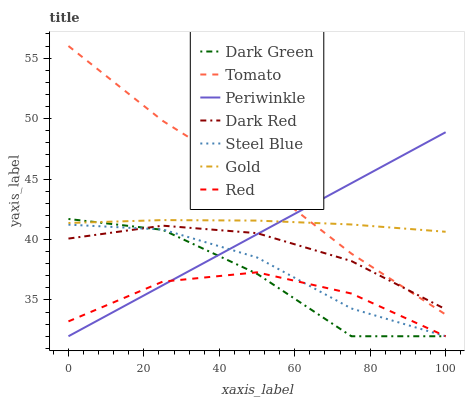Does Red have the minimum area under the curve?
Answer yes or no. Yes. Does Tomato have the maximum area under the curve?
Answer yes or no. Yes. Does Gold have the minimum area under the curve?
Answer yes or no. No. Does Gold have the maximum area under the curve?
Answer yes or no. No. Is Periwinkle the smoothest?
Answer yes or no. Yes. Is Dark Green the roughest?
Answer yes or no. Yes. Is Gold the smoothest?
Answer yes or no. No. Is Gold the roughest?
Answer yes or no. No. Does Steel Blue have the lowest value?
Answer yes or no. Yes. Does Dark Red have the lowest value?
Answer yes or no. No. Does Tomato have the highest value?
Answer yes or no. Yes. Does Gold have the highest value?
Answer yes or no. No. Is Dark Green less than Tomato?
Answer yes or no. Yes. Is Tomato greater than Red?
Answer yes or no. Yes. Does Tomato intersect Periwinkle?
Answer yes or no. Yes. Is Tomato less than Periwinkle?
Answer yes or no. No. Is Tomato greater than Periwinkle?
Answer yes or no. No. Does Dark Green intersect Tomato?
Answer yes or no. No. 